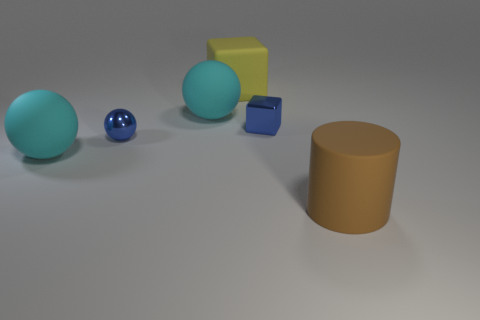Does the brown matte thing have the same size as the yellow matte object?
Your response must be concise. Yes. What is the material of the big thing that is in front of the metallic block and to the left of the big matte cylinder?
Make the answer very short. Rubber. What number of tiny blue objects are the same shape as the large yellow object?
Give a very brief answer. 1. There is a blue thing that is on the right side of the small blue metal sphere; what is it made of?
Provide a succinct answer. Metal. Is the number of yellow objects that are to the left of the brown cylinder less than the number of blue things?
Make the answer very short. Yes. Do the large yellow rubber thing and the big brown rubber thing have the same shape?
Your response must be concise. No. Are there any other things that are the same shape as the big brown thing?
Make the answer very short. No. Are there any tiny gray matte cubes?
Offer a very short reply. No. Does the large yellow object have the same shape as the tiny object behind the blue ball?
Ensure brevity in your answer.  Yes. What is the cube that is behind the matte sphere that is behind the metallic ball made of?
Your response must be concise. Rubber. 